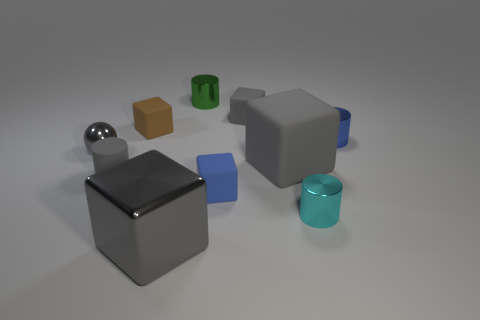Subtract all red cylinders. How many gray blocks are left? 3 Subtract all brown cubes. How many cubes are left? 4 Subtract all small blue matte blocks. How many blocks are left? 4 Subtract all red cylinders. Subtract all brown blocks. How many cylinders are left? 4 Subtract all cylinders. How many objects are left? 6 Add 7 cyan metallic cylinders. How many cyan metallic cylinders are left? 8 Add 6 big metallic things. How many big metallic things exist? 7 Subtract 1 cyan cylinders. How many objects are left? 9 Subtract all tiny blue metallic cylinders. Subtract all brown rubber blocks. How many objects are left? 8 